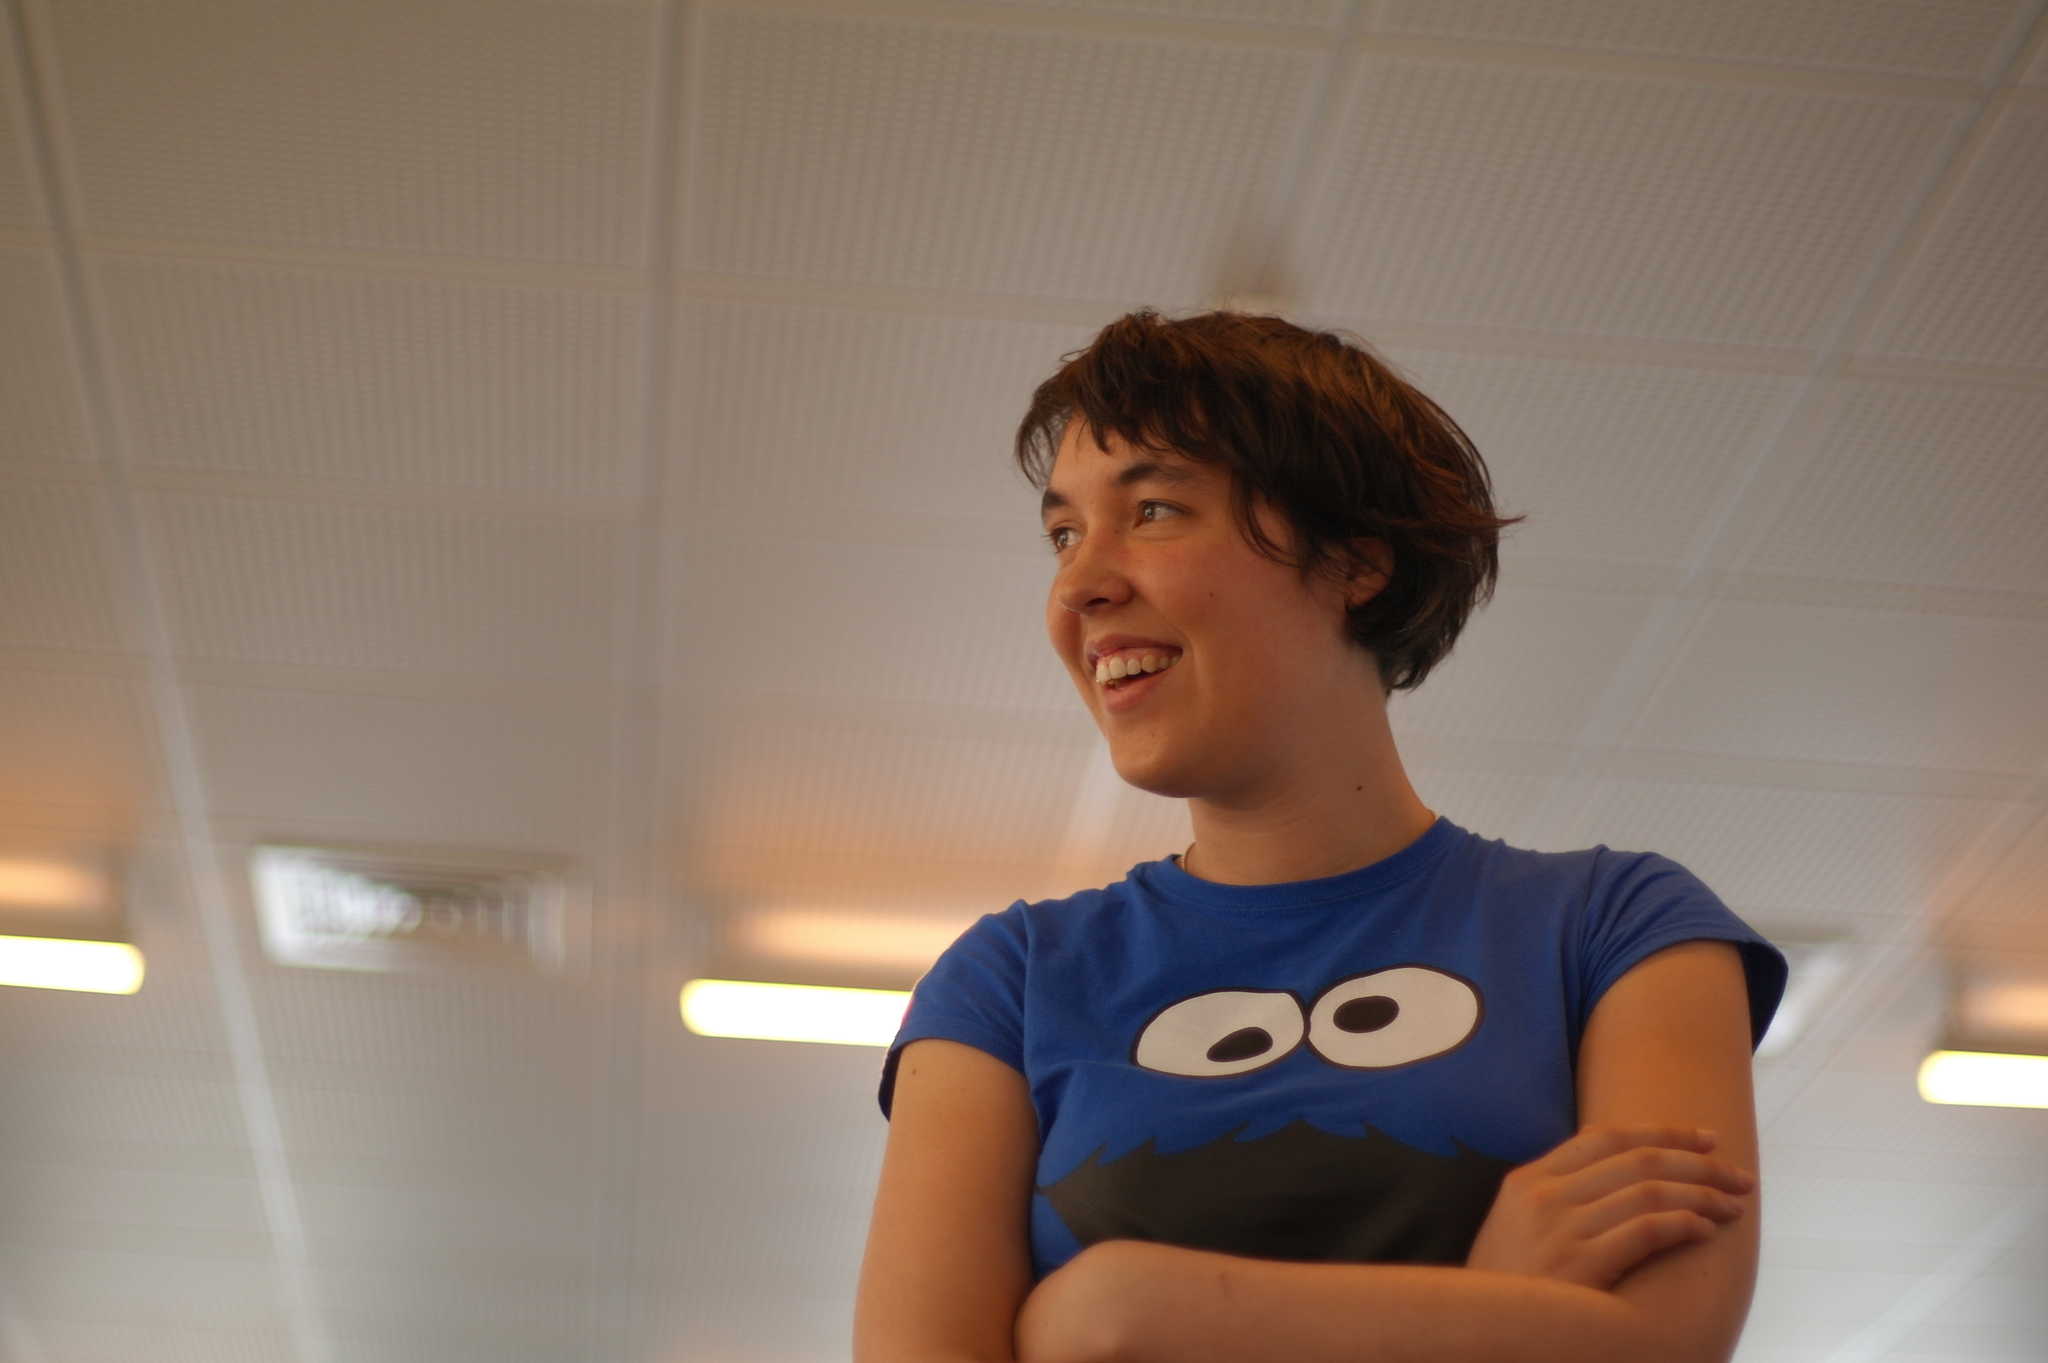Can you describe this image briefly? In this image I can see a person wearing blue, black and white colored t shirt. In the background I can see the ceiling and few lights to the ceiling. 